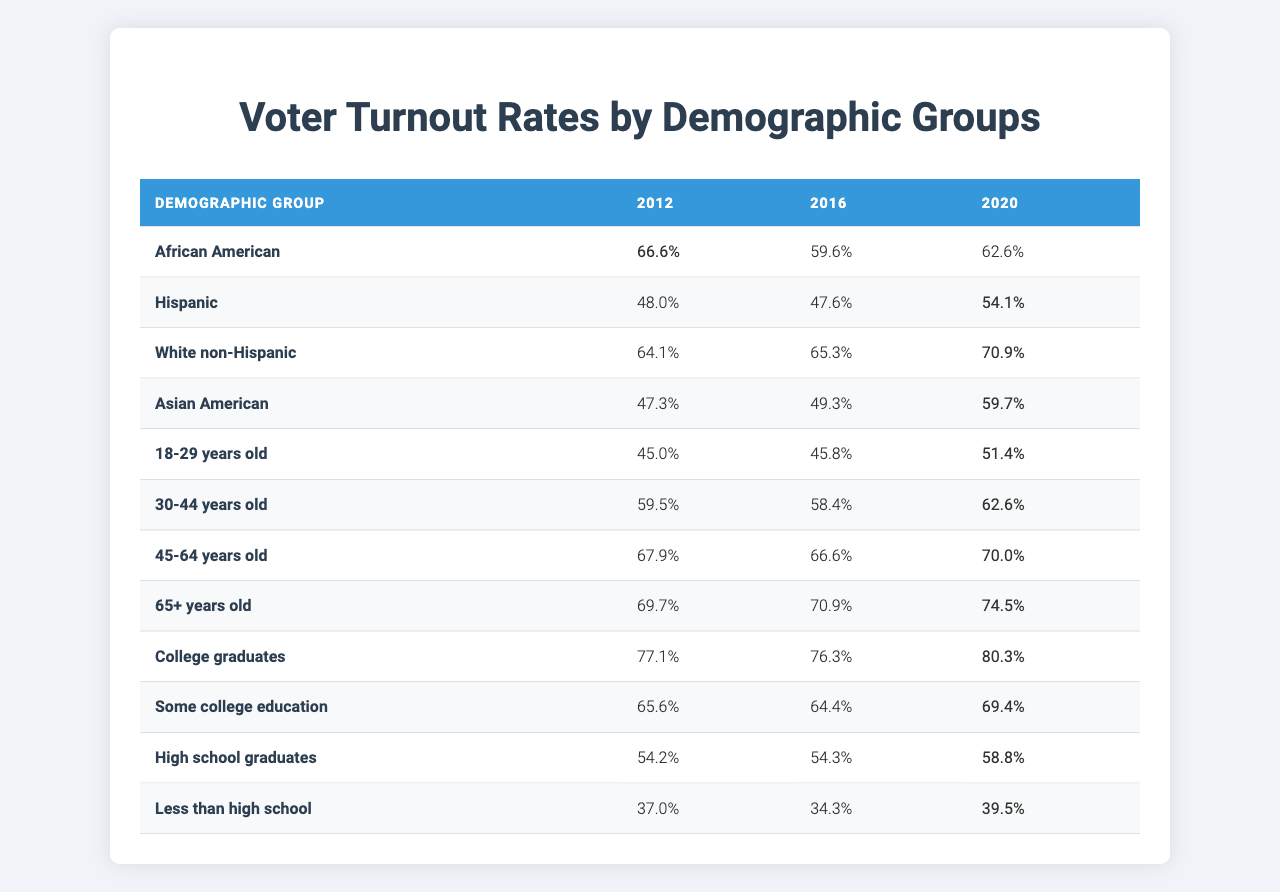What was the voter turnout rate for African Americans in 2020? The table shows that the voter turnout rate for African Americans in 2020 is 62.6%.
Answer: 62.6% Which demographic group had the highest voter turnout in 2012? Upon examining the table for 2012, the highest voter turnout is for College graduates at 77.1%.
Answer: College graduates In which year did Hispanic voter turnout increase the most compared to the previous election? Comparing the turnout rates of Hispanics for 2012 (48.0%), 2016 (47.6%), and 2020 (54.1%), the largest increase is from 2016 to 2020 (54.1 - 47.6 = 6.5).
Answer: From 2016 to 2020 What is the average voter turnout for individuals aged 45-64 over the three elections? To find the average, sum the turnout rates for 45-64 years old: 67.9% (2012) + 66.6% (2016) + 70.0% (2020) = 204.5% total. Divide by 3 to get the average: 204.5/3 = 68.17%.
Answer: 68.2% Did voter turnout for those with less than high school education increase from 2012 to 2020? The turnout rates show 37.0% for 2012 and 39.5% for 2020, indicating an increase of 2.5%. Therefore, the statement is true.
Answer: Yes Which demographic group had the lowest turnout in the 2016 elections, and what was the rate? Checking the 2016 rates, less than high school education had the lowest rate at 34.3%.
Answer: Less than high school, 34.3% What trend do we see in voter turnout for White non-Hispanic individuals from 2012 to 2020? The turnout rates for White non-Hispanic individuals increased from 64.1% in 2012 to 70.9% in 2020, showing a consistent upward trend over the years.
Answer: Increasing trend How much higher was the turnout for College graduates in 2020 compared to those with less than high school? College graduates had a turnout of 80.3% in 2020, while those with less than high school had 39.5%. The difference is 80.3 - 39.5 = 40.8%.
Answer: 40.8% higher Is it true that the turnout rate for 65+ years old demographic was consistently the highest across all three elections? The 65+ age group had turnout rates of 69.7% (2012), 70.9% (2016), and 74.5% (2020). Compared to all other groups, they indeed had the highest rates, confirming the statement is true.
Answer: True What was the difference in turnout rate between the oldest and youngest age groups in 2020? The turnout rate for 65+ years old in 2020 was 74.5%, and for 18-29 years old, it was 51.4%. The difference is 74.5 - 51.4 = 23.1%.
Answer: 23.1% 